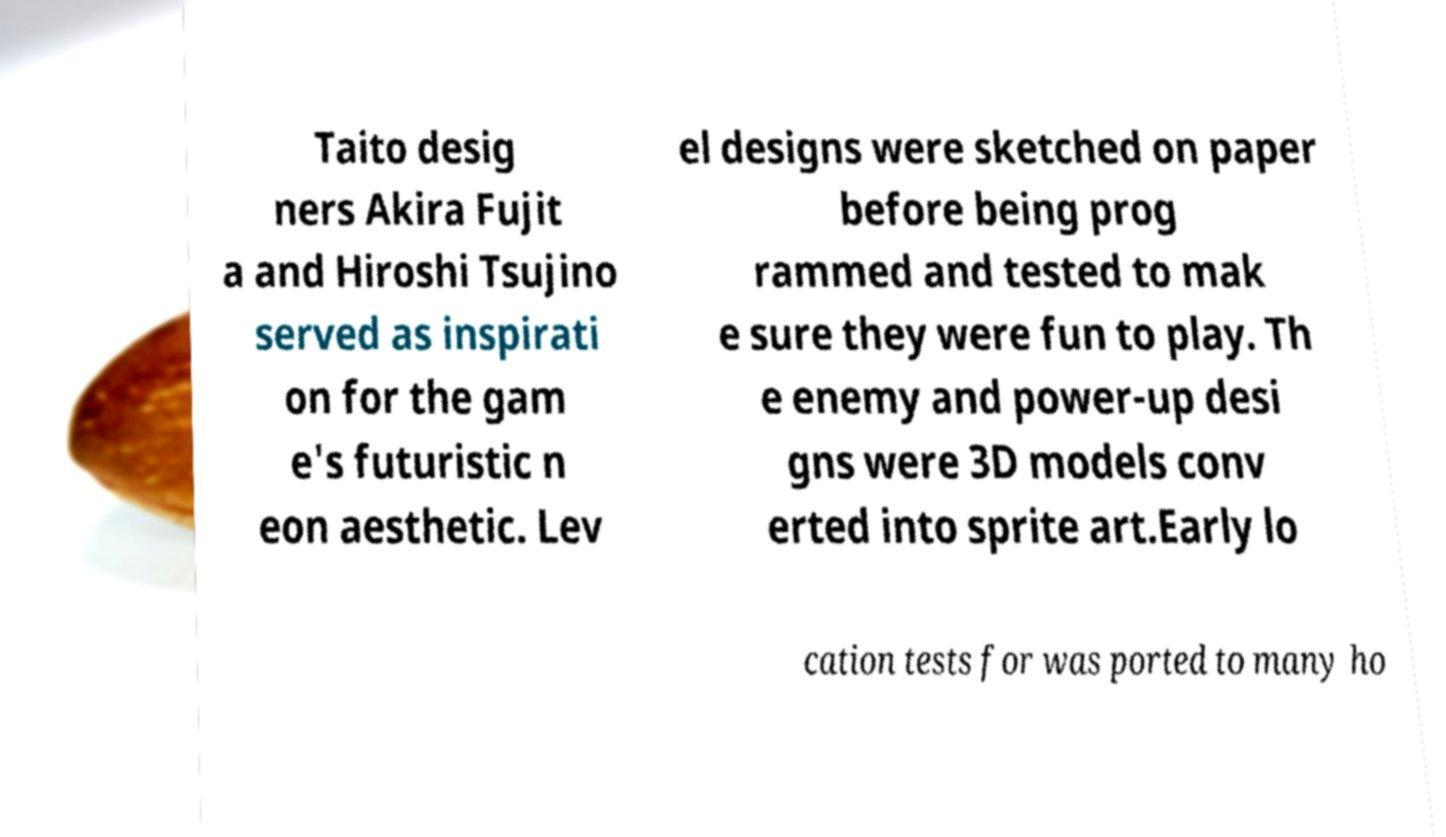Can you read and provide the text displayed in the image?This photo seems to have some interesting text. Can you extract and type it out for me? Taito desig ners Akira Fujit a and Hiroshi Tsujino served as inspirati on for the gam e's futuristic n eon aesthetic. Lev el designs were sketched on paper before being prog rammed and tested to mak e sure they were fun to play. Th e enemy and power-up desi gns were 3D models conv erted into sprite art.Early lo cation tests for was ported to many ho 